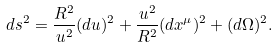<formula> <loc_0><loc_0><loc_500><loc_500>d s ^ { 2 } = \frac { R ^ { 2 } } { u ^ { 2 } } ( d u ) ^ { 2 } + \frac { u ^ { 2 } } { R ^ { 2 } } ( d x ^ { \mu } ) ^ { 2 } + ( d \Omega ) ^ { 2 } .</formula> 